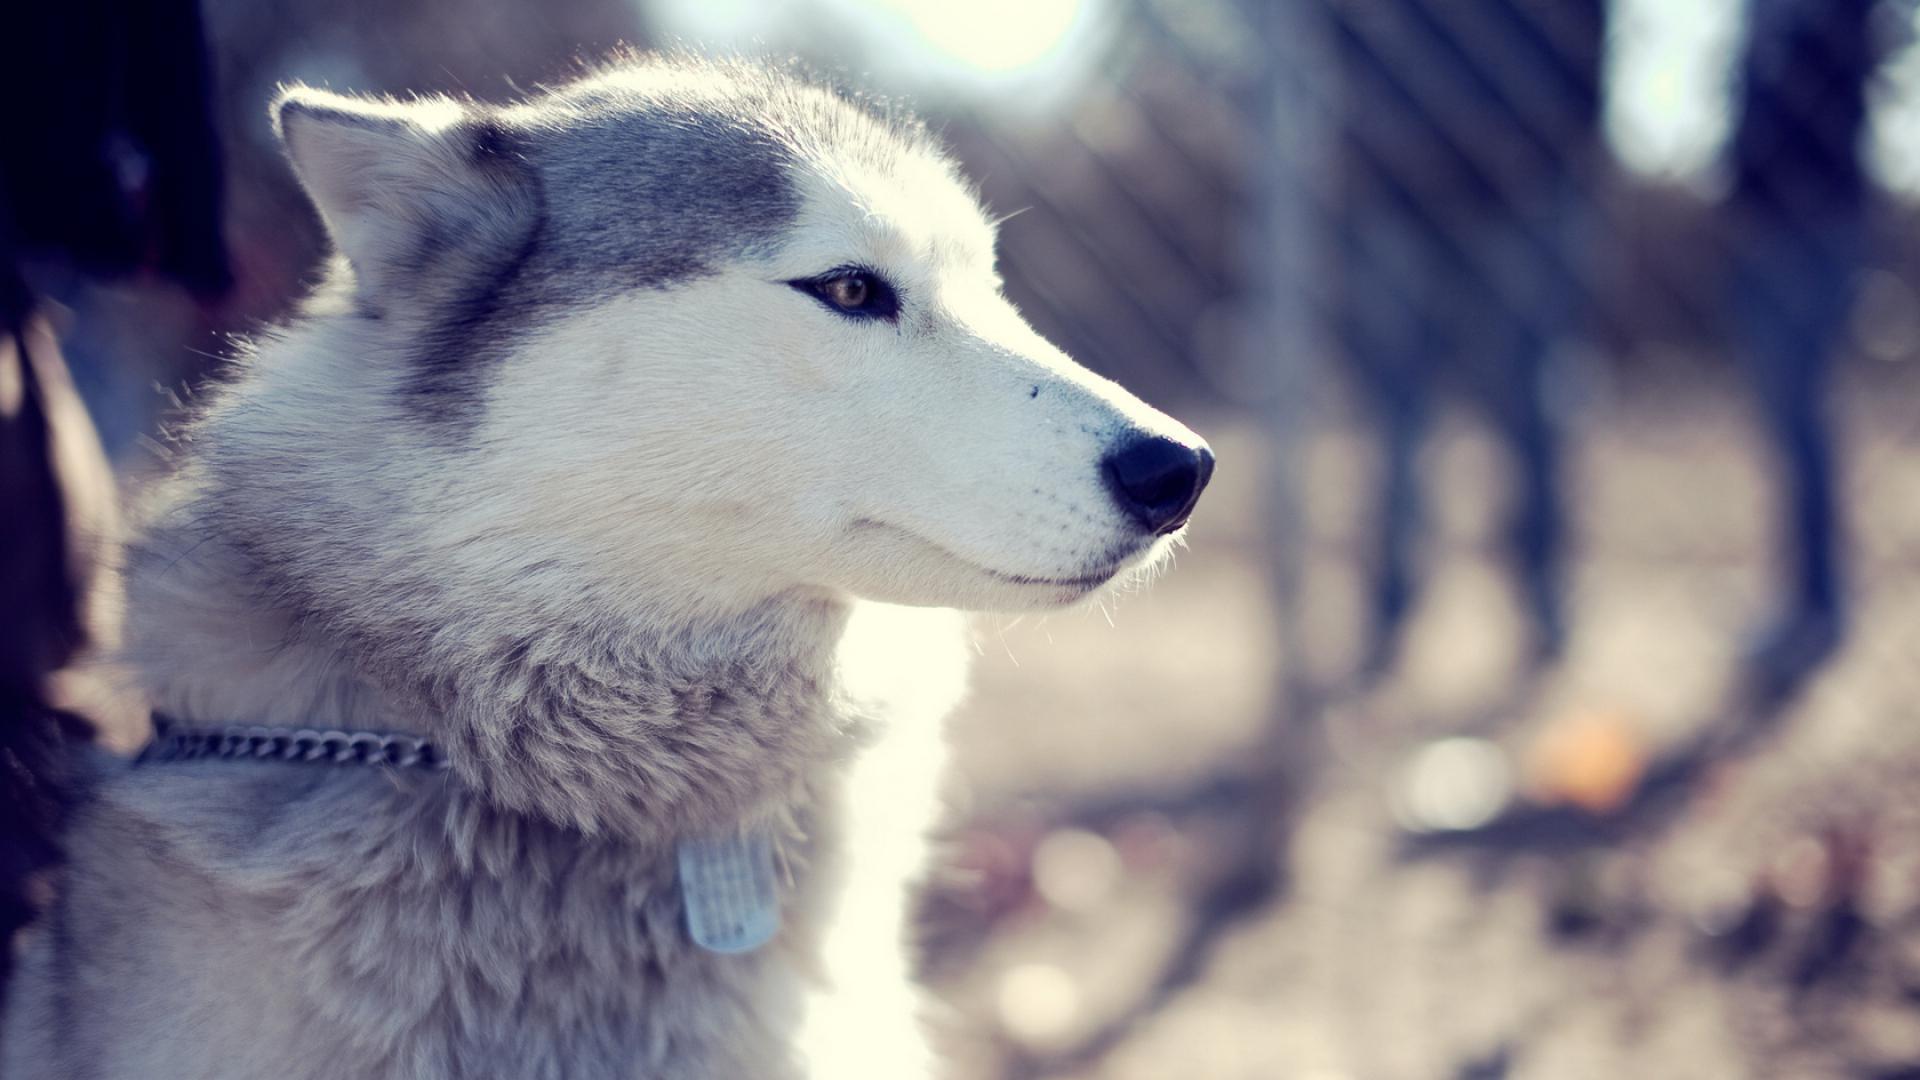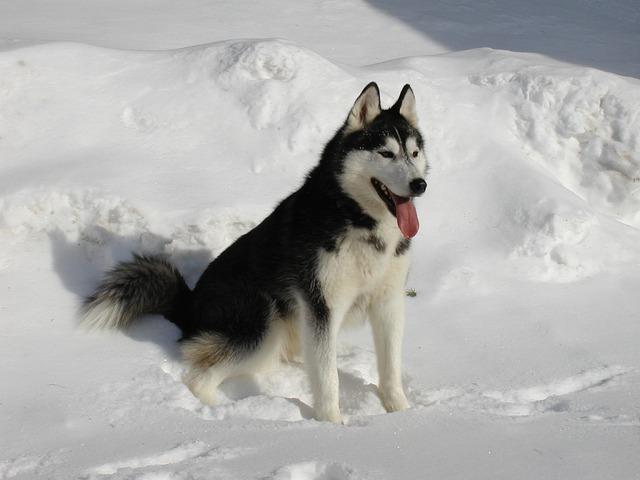The first image is the image on the left, the second image is the image on the right. Assess this claim about the two images: "The right image shows two husky dogs of similar age and size, posed with their heads side-by-side, showing similar expressions.". Correct or not? Answer yes or no. No. The first image is the image on the left, the second image is the image on the right. Analyze the images presented: Is the assertion "The right image contains exactly two dogs." valid? Answer yes or no. No. 